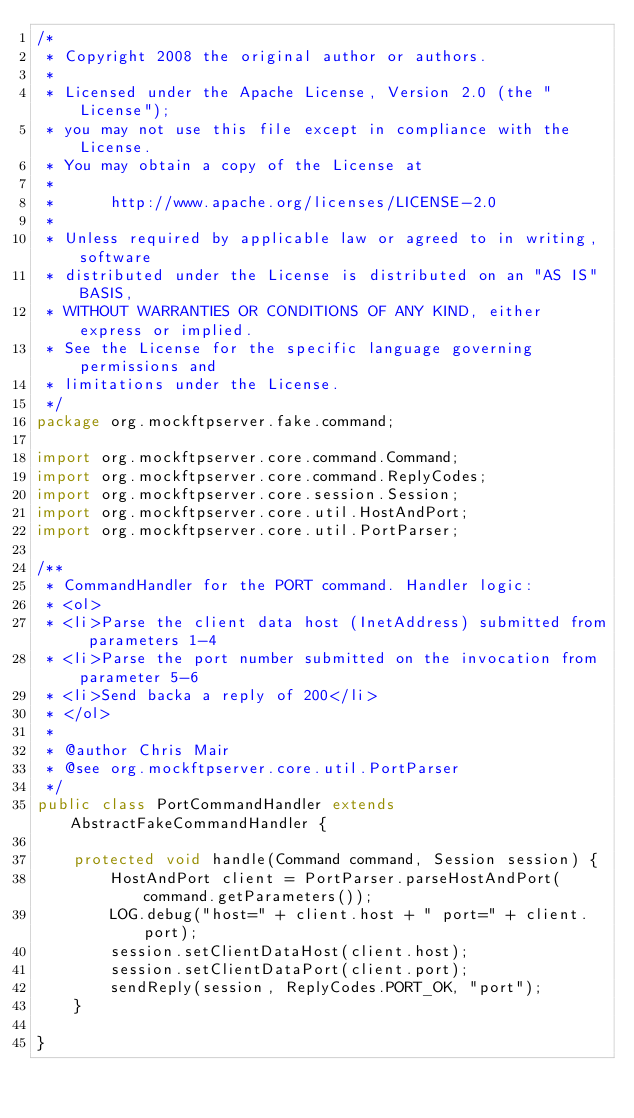<code> <loc_0><loc_0><loc_500><loc_500><_Java_>/*
 * Copyright 2008 the original author or authors.
 *
 * Licensed under the Apache License, Version 2.0 (the "License");
 * you may not use this file except in compliance with the License.
 * You may obtain a copy of the License at
 *
 *      http://www.apache.org/licenses/LICENSE-2.0
 *
 * Unless required by applicable law or agreed to in writing, software
 * distributed under the License is distributed on an "AS IS" BASIS,
 * WITHOUT WARRANTIES OR CONDITIONS OF ANY KIND, either express or implied.
 * See the License for the specific language governing permissions and
 * limitations under the License.
 */
package org.mockftpserver.fake.command;

import org.mockftpserver.core.command.Command;
import org.mockftpserver.core.command.ReplyCodes;
import org.mockftpserver.core.session.Session;
import org.mockftpserver.core.util.HostAndPort;
import org.mockftpserver.core.util.PortParser;

/**
 * CommandHandler for the PORT command. Handler logic:
 * <ol>
 * <li>Parse the client data host (InetAddress) submitted from parameters 1-4
 * <li>Parse the port number submitted on the invocation from parameter 5-6
 * <li>Send backa a reply of 200</li>
 * </ol>
 *
 * @author Chris Mair
 * @see org.mockftpserver.core.util.PortParser
 */
public class PortCommandHandler extends AbstractFakeCommandHandler {

    protected void handle(Command command, Session session) {
        HostAndPort client = PortParser.parseHostAndPort(command.getParameters());
        LOG.debug("host=" + client.host + " port=" + client.port);
        session.setClientDataHost(client.host);
        session.setClientDataPort(client.port);
        sendReply(session, ReplyCodes.PORT_OK, "port");
    }

}</code> 